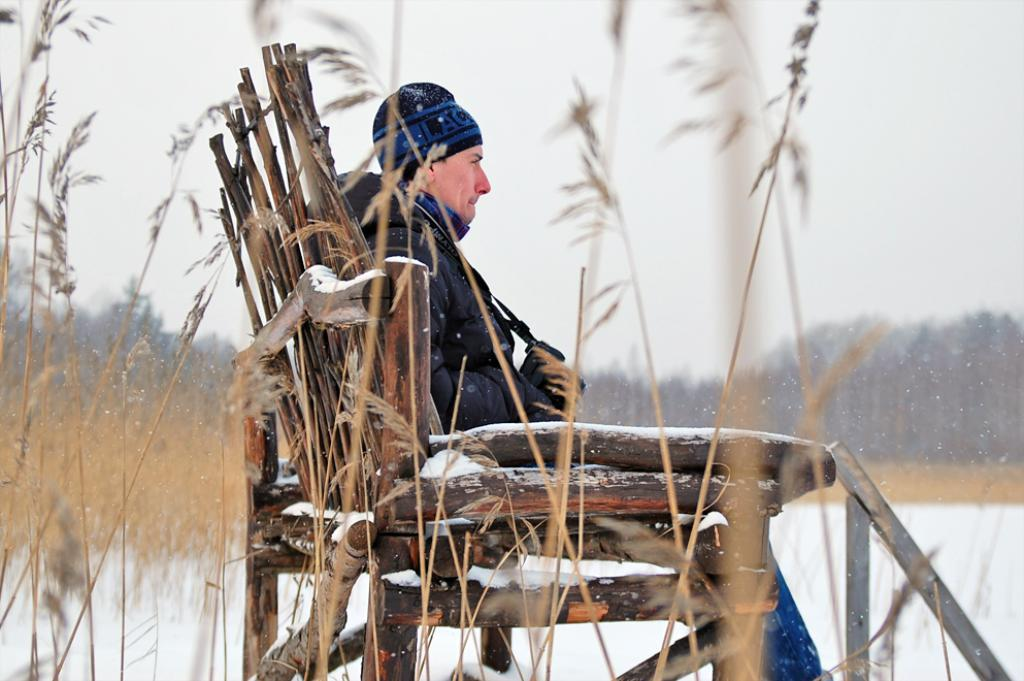What is the main subject of the picture? The main subject of the picture is a man. What is the man wearing? The man is wearing a blazer and a cap. What object does the man have in the picture? The man has a camera. Where is the man sitting in the image? The man is sitting on a bench. What type of vegetation can be seen in the image? There are plants and trees in the image. What is the weather like in the image? The presence of snow suggests that it is cold and possibly winter. What is visible in the background of the image? The sky is visible in the background of the image. What type of dress is the man wearing in the image? The man is not wearing a dress in the image; he is wearing a blazer and a cap. What hobbies does the man enjoy while sitting near the ocean in the image? There is no ocean present in the image, and therefore no indication of the man's hobbies related to it. 